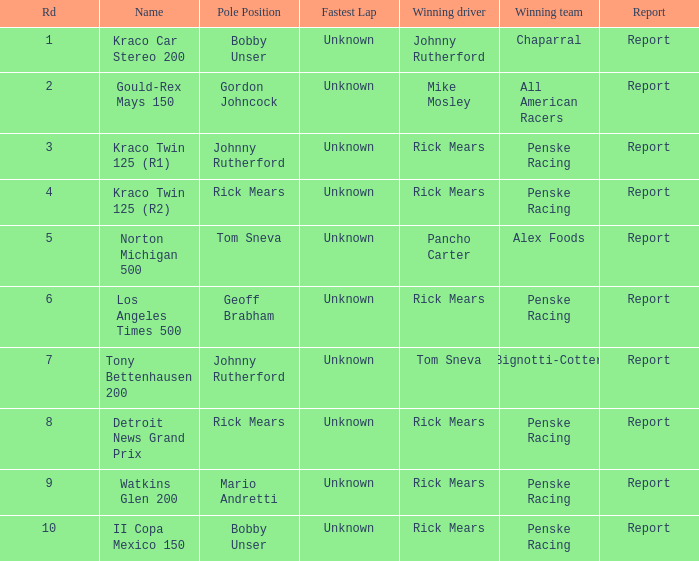Which team won the race, los angeles times 500? Penske Racing. 